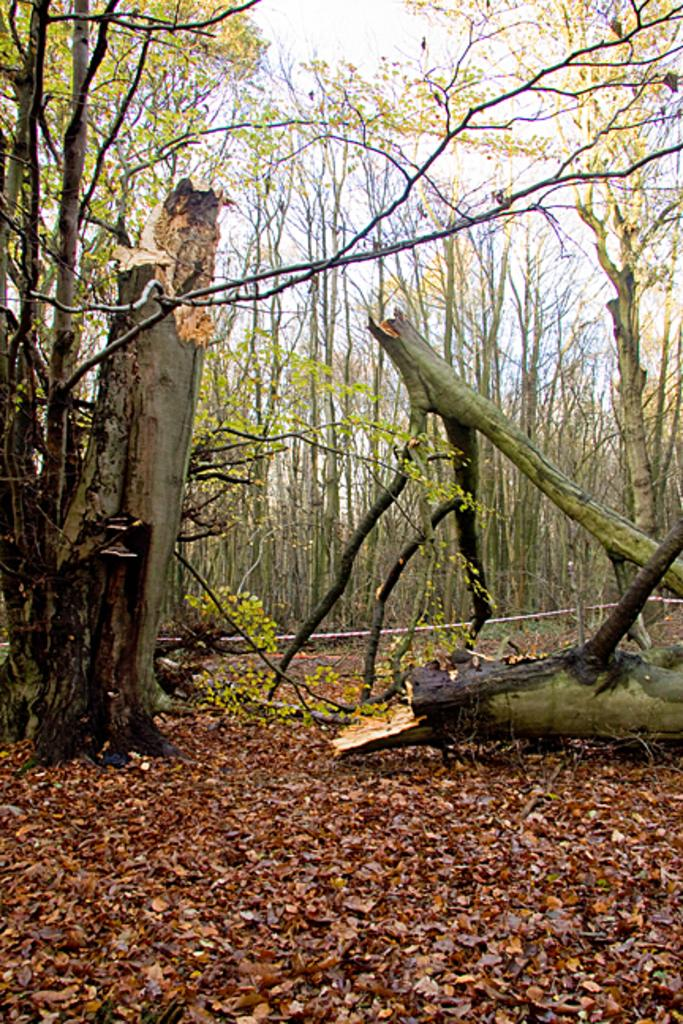What type of vegetation can be seen in the image? There are trees and plants visible in the image. What is the condition of the ground in the image? The ground is visible with dried leaves. What object can be seen in the image that might be used for various purposes? There is a rope in the image. What part of the natural environment is visible in the image? The sky is visible in the image. What type of tomatoes can be seen growing on the trees in the image? There are no tomatoes present in the image, and tomatoes do not grow on trees. 